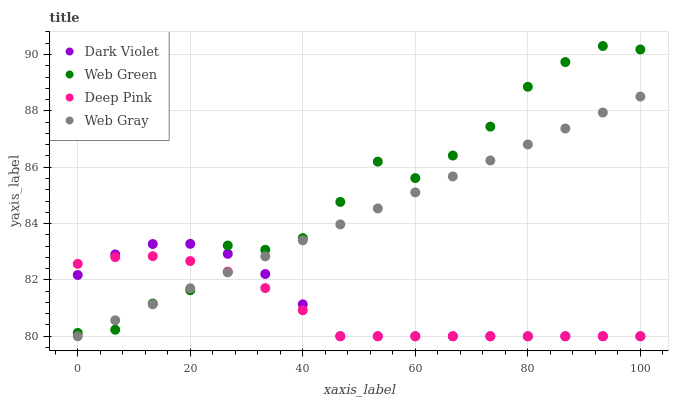Does Deep Pink have the minimum area under the curve?
Answer yes or no. Yes. Does Web Green have the maximum area under the curve?
Answer yes or no. Yes. Does Web Gray have the minimum area under the curve?
Answer yes or no. No. Does Web Gray have the maximum area under the curve?
Answer yes or no. No. Is Web Gray the smoothest?
Answer yes or no. Yes. Is Web Green the roughest?
Answer yes or no. Yes. Is Web Green the smoothest?
Answer yes or no. No. Is Web Gray the roughest?
Answer yes or no. No. Does Deep Pink have the lowest value?
Answer yes or no. Yes. Does Web Green have the lowest value?
Answer yes or no. No. Does Web Green have the highest value?
Answer yes or no. Yes. Does Web Gray have the highest value?
Answer yes or no. No. Does Dark Violet intersect Web Green?
Answer yes or no. Yes. Is Dark Violet less than Web Green?
Answer yes or no. No. Is Dark Violet greater than Web Green?
Answer yes or no. No. 